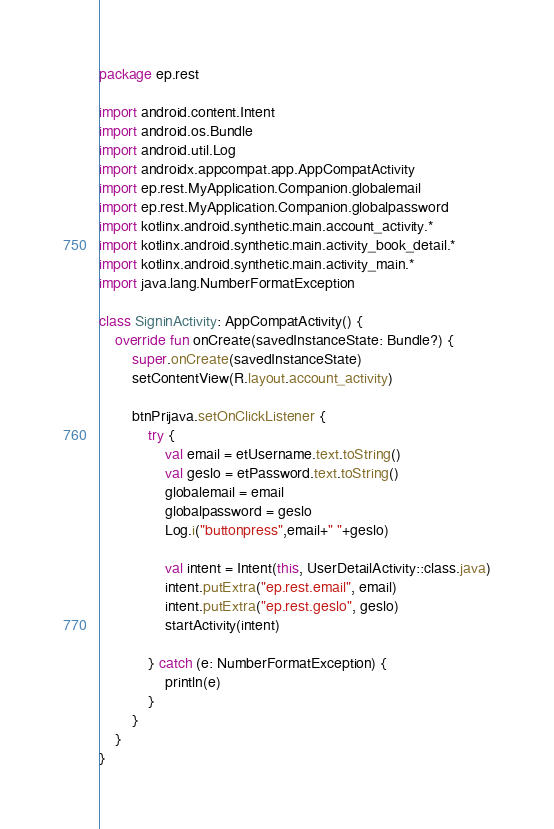<code> <loc_0><loc_0><loc_500><loc_500><_Kotlin_>package ep.rest

import android.content.Intent
import android.os.Bundle
import android.util.Log
import androidx.appcompat.app.AppCompatActivity
import ep.rest.MyApplication.Companion.globalemail
import ep.rest.MyApplication.Companion.globalpassword
import kotlinx.android.synthetic.main.account_activity.*
import kotlinx.android.synthetic.main.activity_book_detail.*
import kotlinx.android.synthetic.main.activity_main.*
import java.lang.NumberFormatException

class SigninActivity: AppCompatActivity() {
    override fun onCreate(savedInstanceState: Bundle?) {
        super.onCreate(savedInstanceState)
        setContentView(R.layout.account_activity)

        btnPrijava.setOnClickListener {
            try {
                val email = etUsername.text.toString()
                val geslo = etPassword.text.toString()
                globalemail = email
                globalpassword = geslo
                Log.i("buttonpress",email+" "+geslo)

                val intent = Intent(this, UserDetailActivity::class.java)
                intent.putExtra("ep.rest.email", email)
                intent.putExtra("ep.rest.geslo", geslo)
                startActivity(intent)

            } catch (e: NumberFormatException) {
                println(e)
            }
        }
    }
}</code> 